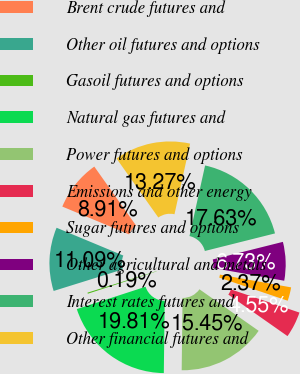Convert chart to OTSL. <chart><loc_0><loc_0><loc_500><loc_500><pie_chart><fcel>Brent crude futures and<fcel>Other oil futures and options<fcel>Gasoil futures and options<fcel>Natural gas futures and<fcel>Power futures and options<fcel>Emissions and other energy<fcel>Sugar futures and options<fcel>Other agricultural and metals<fcel>Interest rates futures and<fcel>Other financial futures and<nl><fcel>8.91%<fcel>11.09%<fcel>0.19%<fcel>19.81%<fcel>15.45%<fcel>4.55%<fcel>2.37%<fcel>6.73%<fcel>17.63%<fcel>13.27%<nl></chart> 